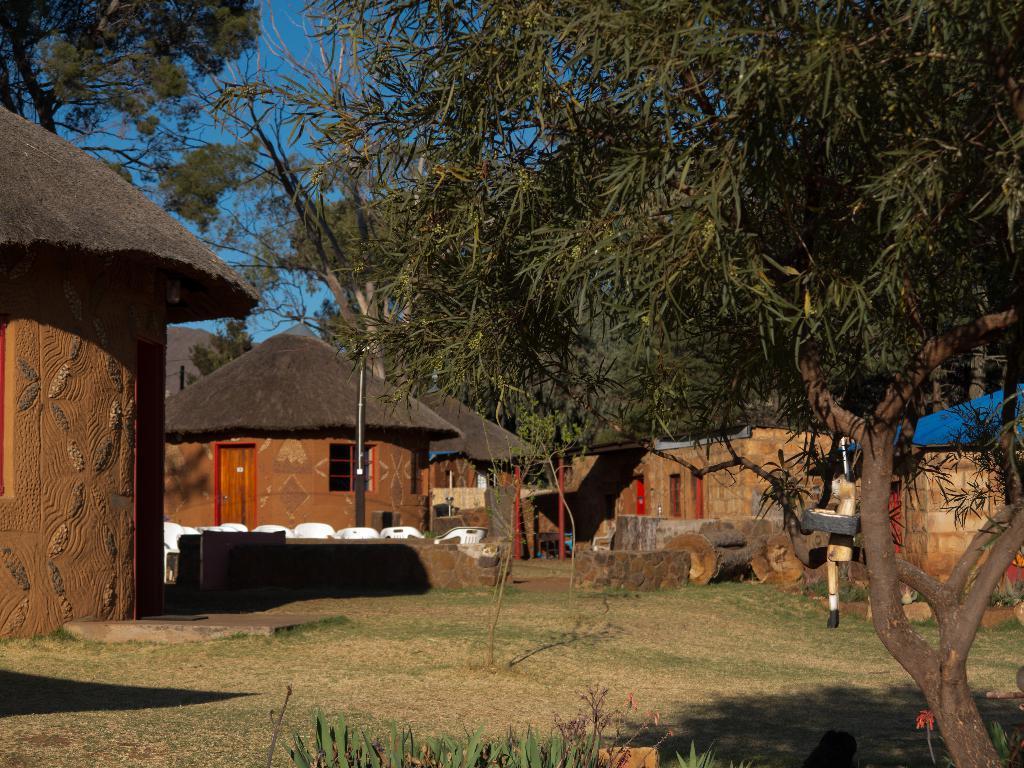Please provide a concise description of this image. Here we can see huts, chairs, and trees. This is grass. In the background we can see sky. 